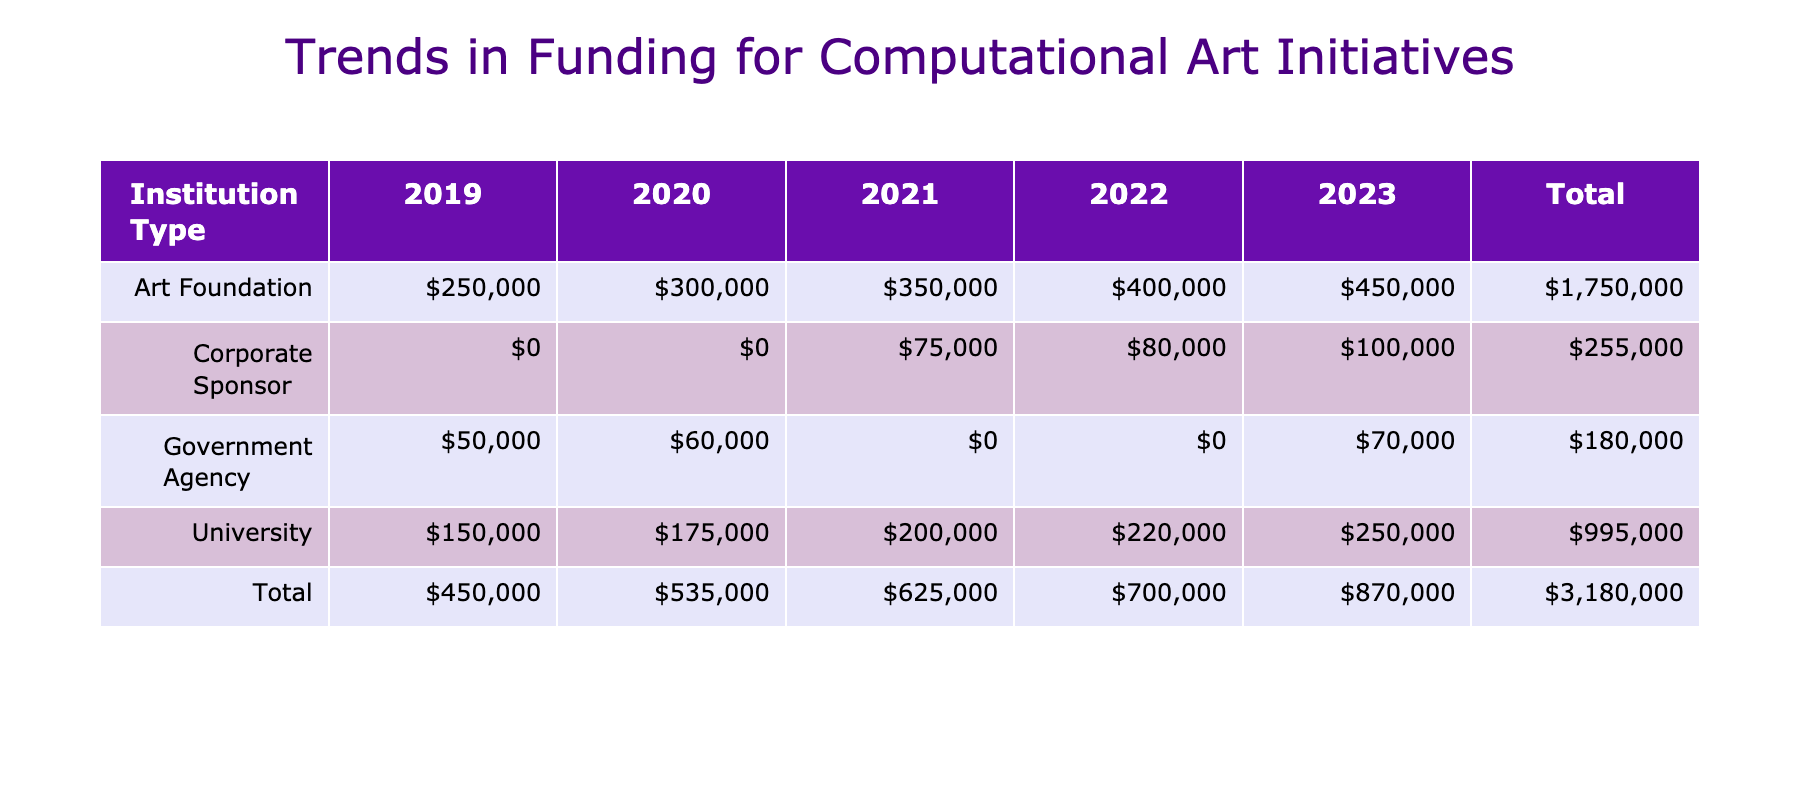What was the total funding amount provided by Art Foundations in 2021? From the table, the funding amount for Art Foundations in 2021 is listed as $350,000. This is the total funding provided by this institution type for that year.
Answer: $350,000 Which year saw the highest funding amount from Corporate Sponsors? Looking at the table, the funding amount from Corporate Sponsors for each year is as follows: $75,000 in 2021, $80,000 in 2022, and $100,000 in 2023. The highest amount is $100,000 in 2023.
Answer: $100,000 Did Government Agencies provide any funding in 2019? The data indicates that Government Agencies provided a funding amount of $50,000 in 2019. Therefore, the statement is true.
Answer: Yes What is the total funding amount across all years for Universities? By summing the funding amounts for Universities from 2019 to 2023: $150,000 (2019) + $175,000 (2020) + $200,000 (2021) + $220,000 (2022) + $250,000 (2023) equals $1,015,000.
Answer: $1,015,000 On average, how much funding was provided by Government Agencies per year? The total funding by Government Agencies from 2019 to 2023 is $50,000 (2019) + $60,000 (2020) + $0 (2021, no data) + $0 (2022, no data) + $70,000 (2023) = $180,000. Since there are 5 years, the average is $180,000 / 5 = $36,000.
Answer: $36,000 Which institution type received the least total funding in 2020? Summarizing the totals for 2020, Universities received $175,000, Art Foundations received $300,000, and Government Agencies received $60,000. The least funding was from Government Agencies at $60,000.
Answer: Government Agencies What was the growth in funding for Art Foundations from 2020 to 2023? For Art Foundations, the funding amounts are $300,000 in 2020 and $450,000 in 2023. The growth can be calculated as $450,000 - $300,000 = $150,000, indicating an increase in funding over these years.
Answer: $150,000 